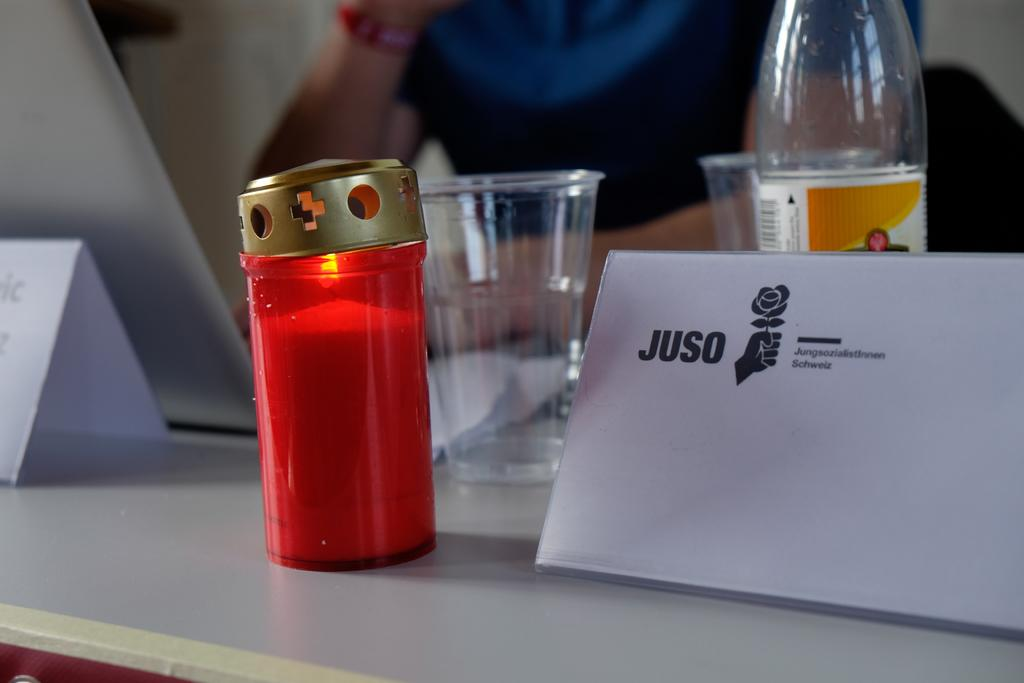<image>
Relay a brief, clear account of the picture shown. Sitting on the table is a candle in a red jar and and envelope with name JUSO. 